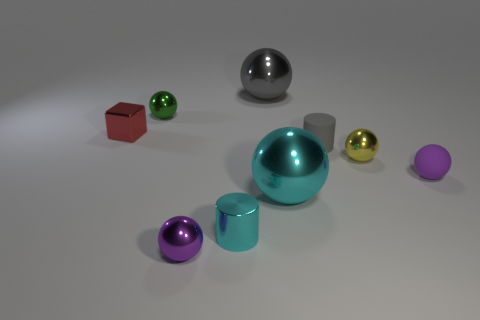There is a object that is the same color as the shiny cylinder; what is it made of?
Your response must be concise. Metal. How many blocks are small gray objects or yellow metal objects?
Your answer should be compact. 0. Is there a yellow object that has the same shape as the tiny purple matte thing?
Provide a short and direct response. Yes. What number of other things are there of the same color as the metallic cylinder?
Provide a succinct answer. 1. Is the number of green shiny things left of the red metal thing less than the number of red matte cylinders?
Provide a short and direct response. No. What number of tiny metal balls are there?
Keep it short and to the point. 3. How many other cyan cylinders are the same material as the tiny cyan cylinder?
Offer a very short reply. 0. How many things are things that are in front of the tiny cyan cylinder or purple metal things?
Ensure brevity in your answer.  1. Are there fewer yellow metallic objects that are behind the small red shiny block than tiny yellow spheres that are in front of the cyan shiny ball?
Keep it short and to the point. No. There is a tiny purple rubber sphere; are there any small yellow things in front of it?
Offer a terse response. No. 